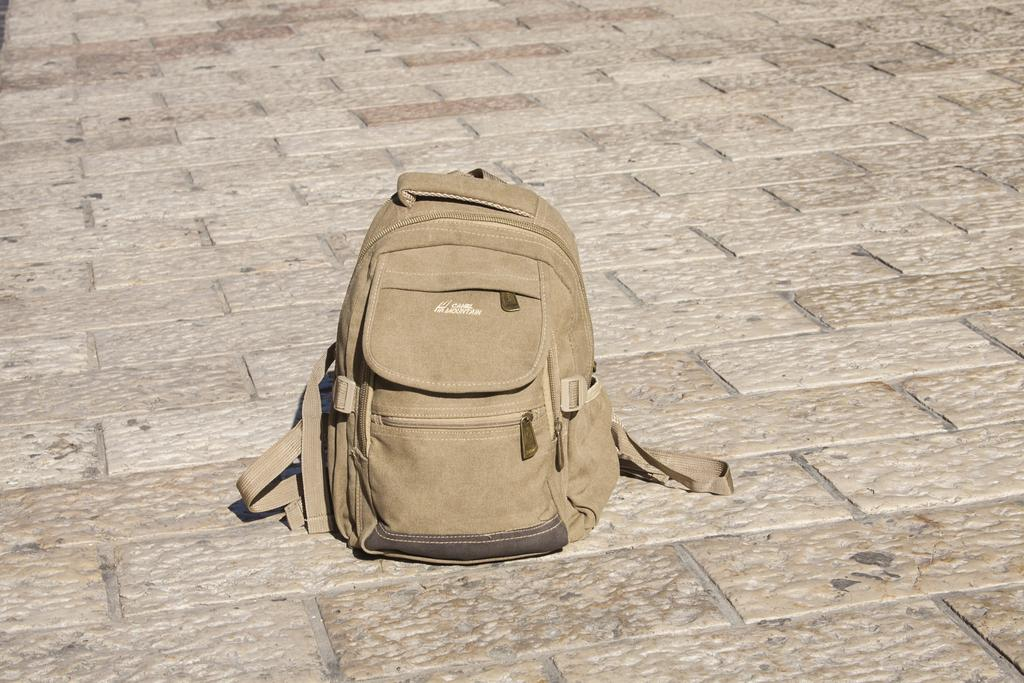What type of bag is in the image? There is a backpack bag in the image. Where is the bag located in the image? The bag is placed on the floor. What is the color of the bag? The bag is light brown in color. How many zips does the bag have? The bag has three zips. What is the purpose of the zips on the bag? The zips are used to open and close the bag. Is there a handle on the bag? Yes, there is a handle at the top of the bag. Can you see a goat using the backpack bag as a shelter in the image? No, there is no goat or any other animal present in the image. The image only shows a backpack bag placed on the floor. 